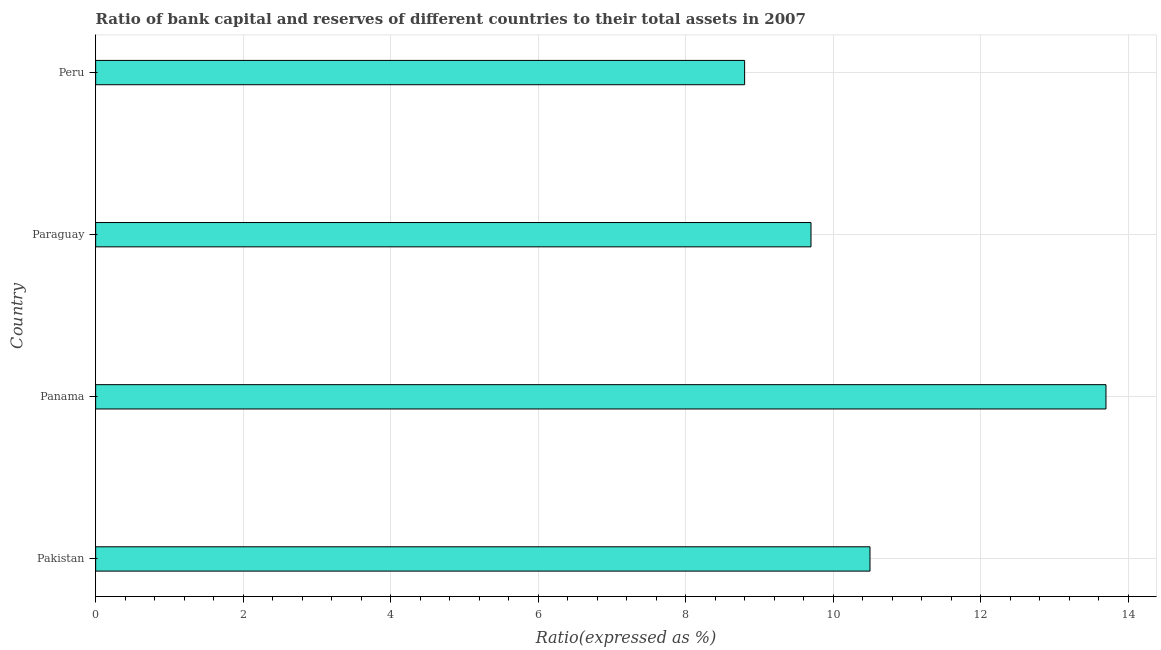Does the graph contain any zero values?
Offer a very short reply. No. Does the graph contain grids?
Your answer should be very brief. Yes. What is the title of the graph?
Your response must be concise. Ratio of bank capital and reserves of different countries to their total assets in 2007. What is the label or title of the X-axis?
Make the answer very short. Ratio(expressed as %). What is the label or title of the Y-axis?
Provide a short and direct response. Country. What is the bank capital to assets ratio in Paraguay?
Give a very brief answer. 9.7. Across all countries, what is the maximum bank capital to assets ratio?
Provide a short and direct response. 13.7. Across all countries, what is the minimum bank capital to assets ratio?
Keep it short and to the point. 8.8. In which country was the bank capital to assets ratio maximum?
Provide a short and direct response. Panama. In which country was the bank capital to assets ratio minimum?
Offer a very short reply. Peru. What is the sum of the bank capital to assets ratio?
Offer a terse response. 42.7. What is the difference between the bank capital to assets ratio in Panama and Paraguay?
Provide a succinct answer. 4. What is the average bank capital to assets ratio per country?
Offer a terse response. 10.68. What is the ratio of the bank capital to assets ratio in Pakistan to that in Peru?
Offer a very short reply. 1.19. What is the difference between the highest and the second highest bank capital to assets ratio?
Your response must be concise. 3.2. What is the difference between the highest and the lowest bank capital to assets ratio?
Ensure brevity in your answer.  4.9. In how many countries, is the bank capital to assets ratio greater than the average bank capital to assets ratio taken over all countries?
Offer a very short reply. 1. Are the values on the major ticks of X-axis written in scientific E-notation?
Your response must be concise. No. What is the Ratio(expressed as %) of Peru?
Keep it short and to the point. 8.8. What is the difference between the Ratio(expressed as %) in Panama and Paraguay?
Offer a very short reply. 4. What is the difference between the Ratio(expressed as %) in Panama and Peru?
Provide a succinct answer. 4.9. What is the difference between the Ratio(expressed as %) in Paraguay and Peru?
Offer a very short reply. 0.9. What is the ratio of the Ratio(expressed as %) in Pakistan to that in Panama?
Provide a succinct answer. 0.77. What is the ratio of the Ratio(expressed as %) in Pakistan to that in Paraguay?
Provide a short and direct response. 1.08. What is the ratio of the Ratio(expressed as %) in Pakistan to that in Peru?
Ensure brevity in your answer.  1.19. What is the ratio of the Ratio(expressed as %) in Panama to that in Paraguay?
Give a very brief answer. 1.41. What is the ratio of the Ratio(expressed as %) in Panama to that in Peru?
Give a very brief answer. 1.56. What is the ratio of the Ratio(expressed as %) in Paraguay to that in Peru?
Your answer should be compact. 1.1. 